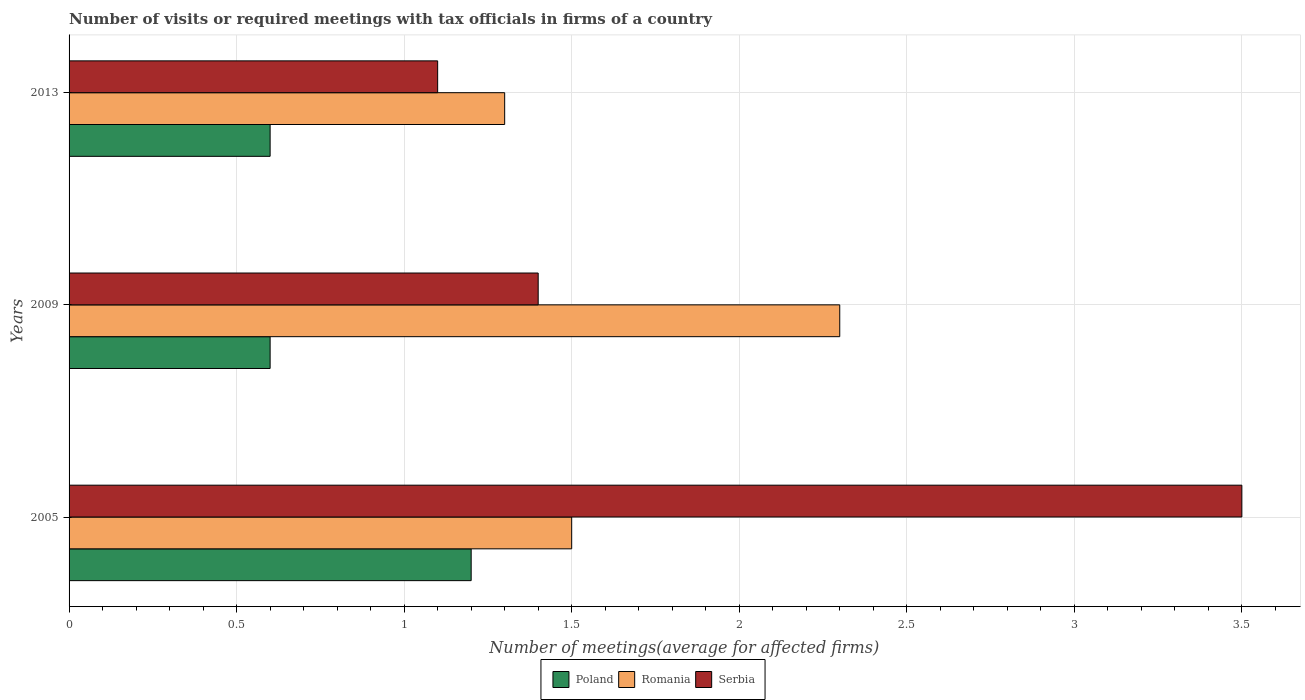Are the number of bars per tick equal to the number of legend labels?
Your response must be concise. Yes. How many bars are there on the 1st tick from the top?
Your answer should be very brief. 3. In how many cases, is the number of bars for a given year not equal to the number of legend labels?
Keep it short and to the point. 0. In which year was the number of meetings in Romania maximum?
Your answer should be compact. 2009. What is the difference between the number of meetings in Romania in 2005 and that in 2009?
Your answer should be very brief. -0.8. What is the difference between the number of meetings in Serbia in 2009 and the number of meetings in Romania in 2013?
Offer a terse response. 0.1. What is the average number of meetings in Poland per year?
Keep it short and to the point. 0.8. What is the ratio of the number of meetings in Poland in 2009 to that in 2013?
Ensure brevity in your answer.  1. Is the number of meetings in Romania in 2005 less than that in 2009?
Offer a terse response. Yes. What is the difference between the highest and the second highest number of meetings in Poland?
Provide a short and direct response. 0.6. What is the difference between the highest and the lowest number of meetings in Romania?
Provide a short and direct response. 1. In how many years, is the number of meetings in Serbia greater than the average number of meetings in Serbia taken over all years?
Make the answer very short. 1. What does the 1st bar from the bottom in 2013 represents?
Offer a terse response. Poland. Are all the bars in the graph horizontal?
Your response must be concise. Yes. What is the difference between two consecutive major ticks on the X-axis?
Ensure brevity in your answer.  0.5. Are the values on the major ticks of X-axis written in scientific E-notation?
Offer a terse response. No. How many legend labels are there?
Make the answer very short. 3. What is the title of the graph?
Your answer should be compact. Number of visits or required meetings with tax officials in firms of a country. Does "Channel Islands" appear as one of the legend labels in the graph?
Offer a terse response. No. What is the label or title of the X-axis?
Your response must be concise. Number of meetings(average for affected firms). What is the Number of meetings(average for affected firms) in Poland in 2005?
Keep it short and to the point. 1.2. What is the Number of meetings(average for affected firms) of Romania in 2005?
Your answer should be very brief. 1.5. What is the Number of meetings(average for affected firms) in Poland in 2009?
Offer a very short reply. 0.6. What is the Number of meetings(average for affected firms) of Serbia in 2009?
Your answer should be very brief. 1.4. What is the Number of meetings(average for affected firms) of Poland in 2013?
Offer a terse response. 0.6. What is the Number of meetings(average for affected firms) of Serbia in 2013?
Give a very brief answer. 1.1. Across all years, what is the maximum Number of meetings(average for affected firms) of Romania?
Offer a terse response. 2.3. What is the total Number of meetings(average for affected firms) of Romania in the graph?
Your response must be concise. 5.1. What is the difference between the Number of meetings(average for affected firms) of Poland in 2005 and that in 2009?
Give a very brief answer. 0.6. What is the difference between the Number of meetings(average for affected firms) of Romania in 2005 and that in 2009?
Provide a succinct answer. -0.8. What is the difference between the Number of meetings(average for affected firms) of Poland in 2005 and that in 2013?
Provide a short and direct response. 0.6. What is the difference between the Number of meetings(average for affected firms) of Romania in 2005 and that in 2013?
Ensure brevity in your answer.  0.2. What is the difference between the Number of meetings(average for affected firms) in Poland in 2009 and that in 2013?
Offer a terse response. 0. What is the difference between the Number of meetings(average for affected firms) of Romania in 2009 and that in 2013?
Your response must be concise. 1. What is the difference between the Number of meetings(average for affected firms) in Poland in 2005 and the Number of meetings(average for affected firms) in Romania in 2009?
Your response must be concise. -1.1. What is the difference between the Number of meetings(average for affected firms) in Poland in 2005 and the Number of meetings(average for affected firms) in Serbia in 2009?
Your answer should be compact. -0.2. What is the difference between the Number of meetings(average for affected firms) of Romania in 2005 and the Number of meetings(average for affected firms) of Serbia in 2009?
Your answer should be very brief. 0.1. What is the difference between the Number of meetings(average for affected firms) in Poland in 2005 and the Number of meetings(average for affected firms) in Serbia in 2013?
Provide a short and direct response. 0.1. What is the difference between the Number of meetings(average for affected firms) of Poland in 2009 and the Number of meetings(average for affected firms) of Romania in 2013?
Make the answer very short. -0.7. What is the difference between the Number of meetings(average for affected firms) in Poland in 2009 and the Number of meetings(average for affected firms) in Serbia in 2013?
Your answer should be very brief. -0.5. What is the difference between the Number of meetings(average for affected firms) of Romania in 2009 and the Number of meetings(average for affected firms) of Serbia in 2013?
Your answer should be compact. 1.2. In the year 2005, what is the difference between the Number of meetings(average for affected firms) of Poland and Number of meetings(average for affected firms) of Serbia?
Your response must be concise. -2.3. In the year 2009, what is the difference between the Number of meetings(average for affected firms) in Poland and Number of meetings(average for affected firms) in Serbia?
Your answer should be very brief. -0.8. In the year 2009, what is the difference between the Number of meetings(average for affected firms) in Romania and Number of meetings(average for affected firms) in Serbia?
Your response must be concise. 0.9. In the year 2013, what is the difference between the Number of meetings(average for affected firms) in Poland and Number of meetings(average for affected firms) in Serbia?
Your answer should be very brief. -0.5. In the year 2013, what is the difference between the Number of meetings(average for affected firms) in Romania and Number of meetings(average for affected firms) in Serbia?
Offer a terse response. 0.2. What is the ratio of the Number of meetings(average for affected firms) in Poland in 2005 to that in 2009?
Provide a short and direct response. 2. What is the ratio of the Number of meetings(average for affected firms) in Romania in 2005 to that in 2009?
Offer a terse response. 0.65. What is the ratio of the Number of meetings(average for affected firms) of Serbia in 2005 to that in 2009?
Your answer should be very brief. 2.5. What is the ratio of the Number of meetings(average for affected firms) in Poland in 2005 to that in 2013?
Ensure brevity in your answer.  2. What is the ratio of the Number of meetings(average for affected firms) of Romania in 2005 to that in 2013?
Ensure brevity in your answer.  1.15. What is the ratio of the Number of meetings(average for affected firms) in Serbia in 2005 to that in 2013?
Keep it short and to the point. 3.18. What is the ratio of the Number of meetings(average for affected firms) of Romania in 2009 to that in 2013?
Make the answer very short. 1.77. What is the ratio of the Number of meetings(average for affected firms) in Serbia in 2009 to that in 2013?
Your answer should be compact. 1.27. What is the difference between the highest and the second highest Number of meetings(average for affected firms) of Poland?
Offer a very short reply. 0.6. What is the difference between the highest and the second highest Number of meetings(average for affected firms) of Serbia?
Ensure brevity in your answer.  2.1. 